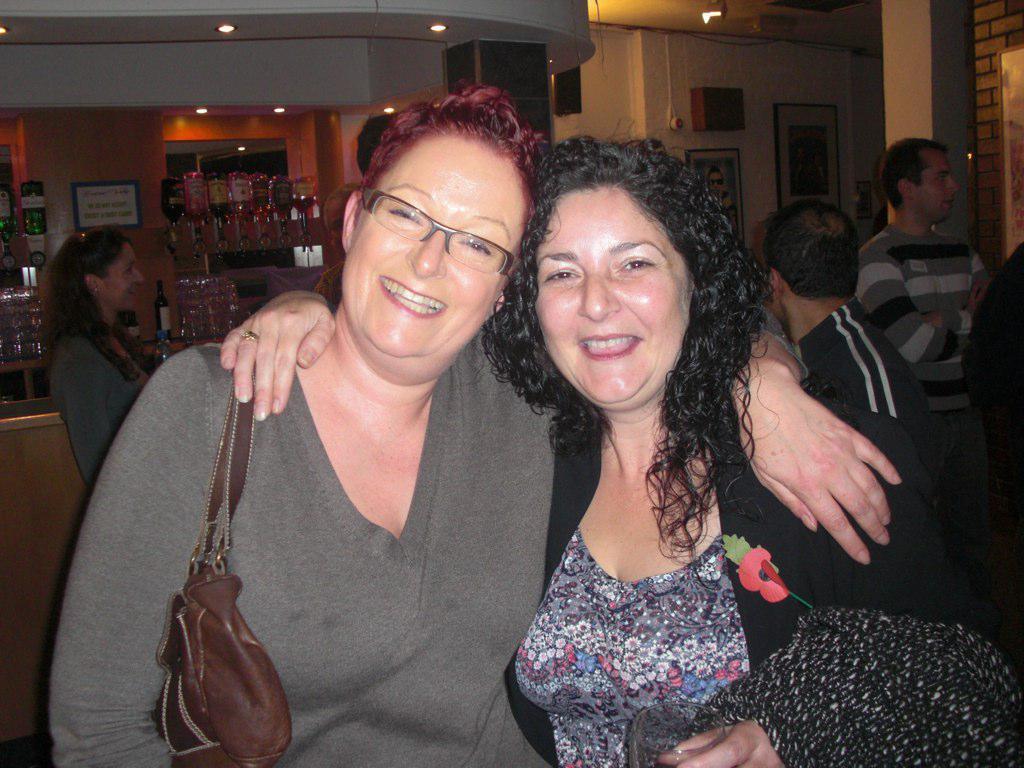Describe this image in one or two sentences. There are two women who are smiling. On right side there is person who is wearing a t-shirt. On left side there is a person who is looking to the person. On the table there is a glasses, bottles. 